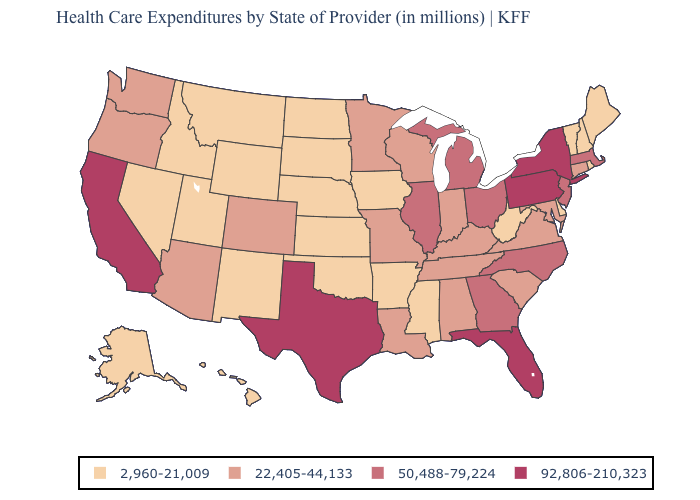Does the first symbol in the legend represent the smallest category?
Answer briefly. Yes. Which states have the highest value in the USA?
Answer briefly. California, Florida, New York, Pennsylvania, Texas. What is the value of Nebraska?
Be succinct. 2,960-21,009. What is the value of Arizona?
Short answer required. 22,405-44,133. Name the states that have a value in the range 22,405-44,133?
Write a very short answer. Alabama, Arizona, Colorado, Connecticut, Indiana, Kentucky, Louisiana, Maryland, Minnesota, Missouri, Oregon, South Carolina, Tennessee, Virginia, Washington, Wisconsin. How many symbols are there in the legend?
Answer briefly. 4. Name the states that have a value in the range 50,488-79,224?
Answer briefly. Georgia, Illinois, Massachusetts, Michigan, New Jersey, North Carolina, Ohio. Name the states that have a value in the range 92,806-210,323?
Give a very brief answer. California, Florida, New York, Pennsylvania, Texas. What is the lowest value in states that border Montana?
Answer briefly. 2,960-21,009. Among the states that border Wisconsin , does Iowa have the highest value?
Answer briefly. No. Name the states that have a value in the range 22,405-44,133?
Answer briefly. Alabama, Arizona, Colorado, Connecticut, Indiana, Kentucky, Louisiana, Maryland, Minnesota, Missouri, Oregon, South Carolina, Tennessee, Virginia, Washington, Wisconsin. What is the value of Minnesota?
Be succinct. 22,405-44,133. Among the states that border Kansas , which have the highest value?
Write a very short answer. Colorado, Missouri. Does the first symbol in the legend represent the smallest category?
Keep it brief. Yes. What is the value of South Carolina?
Write a very short answer. 22,405-44,133. 